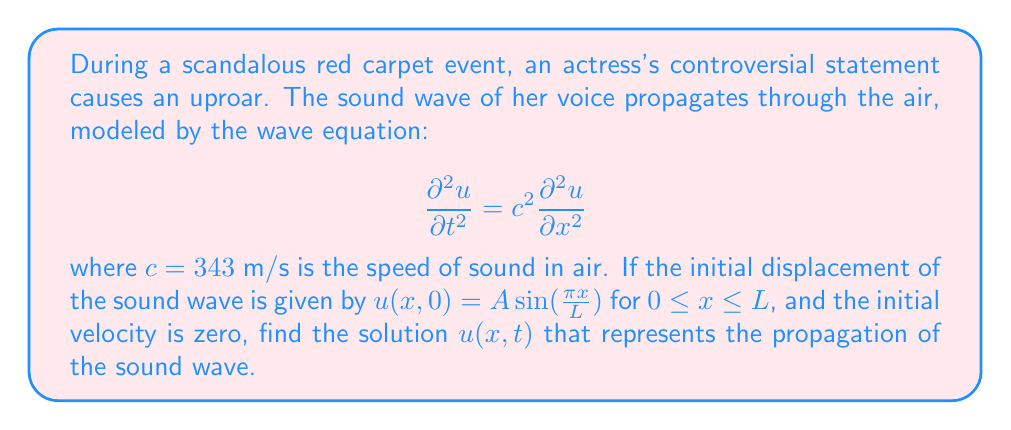Provide a solution to this math problem. To solve this wave equation problem, we'll follow these steps:

1) The general solution for the wave equation with the given initial conditions is:

   $$u(x,t) = f(x-ct) + g(x+ct)$$

   where $f$ and $g$ are arbitrary functions.

2) Given the initial conditions:
   
   $u(x,0) = A \sin(\frac{\pi x}{L})$ and $\frac{\partial u}{\partial t}(x,0) = 0$

3) Using D'Alembert's formula, we can write:

   $$u(x,t) = \frac{1}{2}[f(x-ct) + f(x+ct)]$$

   where $f(x) = A \sin(\frac{\pi x}{L})$

4) Substituting this into our solution:

   $$u(x,t) = \frac{1}{2}[A \sin(\frac{\pi (x-ct)}{L}) + A \sin(\frac{\pi (x+ct)}{L})]$$

5) Using the trigonometric identity for the sum of sines:

   $$\sin A + \sin B = 2 \sin(\frac{A+B}{2}) \cos(\frac{A-B}{2})$$

6) Applying this to our equation:

   $$u(x,t) = A \sin(\frac{\pi x}{L}) \cos(\frac{\pi ct}{L})$$

This is the final solution representing the propagation of the sound wave.
Answer: $u(x,t) = A \sin(\frac{\pi x}{L}) \cos(\frac{\pi ct}{L})$ 